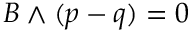Convert formula to latex. <formula><loc_0><loc_0><loc_500><loc_500>B \wedge ( p - q ) = 0</formula> 